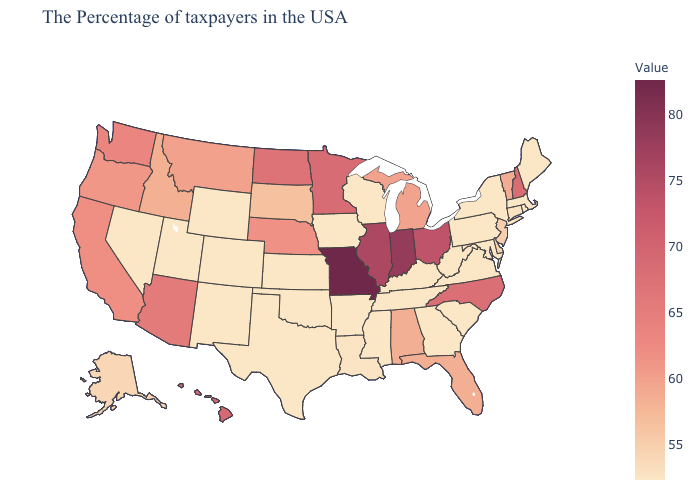Which states have the highest value in the USA?
Concise answer only. Missouri. Among the states that border Wisconsin , does Illinois have the highest value?
Answer briefly. Yes. Which states have the lowest value in the USA?
Answer briefly. Maine, Massachusetts, Rhode Island, New York, Maryland, Pennsylvania, Virginia, South Carolina, West Virginia, Georgia, Kentucky, Tennessee, Wisconsin, Mississippi, Arkansas, Iowa, Kansas, Oklahoma, Texas, Wyoming, Colorado, New Mexico, Utah, Nevada. Among the states that border Kentucky , does Virginia have the highest value?
Concise answer only. No. Which states have the highest value in the USA?
Quick response, please. Missouri. Does West Virginia have a lower value than Arizona?
Short answer required. Yes. Which states have the lowest value in the USA?
Concise answer only. Maine, Massachusetts, Rhode Island, New York, Maryland, Pennsylvania, Virginia, South Carolina, West Virginia, Georgia, Kentucky, Tennessee, Wisconsin, Mississippi, Arkansas, Iowa, Kansas, Oklahoma, Texas, Wyoming, Colorado, New Mexico, Utah, Nevada. 